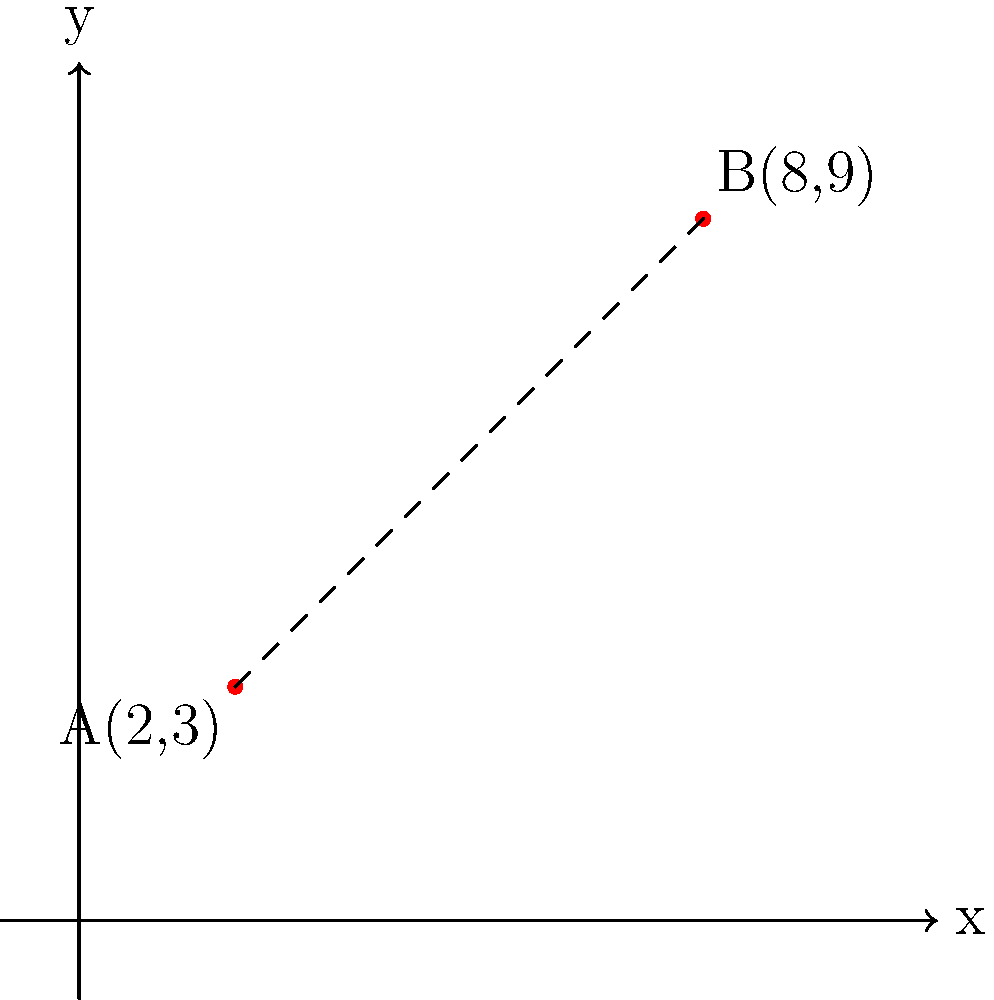In developing a meditation app, you're working on a feature that visualizes sound waves. Two peaks in a particular ambient soundscape are represented as points A(2,3) and B(8,9) on a coordinate system. Calculate the distance between these two sound wave peaks to help determine the spatial effect in the audio mix. To find the distance between two points in a coordinate system, we can use the distance formula, which is derived from the Pythagorean theorem:

$$d = \sqrt{(x_2 - x_1)^2 + (y_2 - y_1)^2}$$

Where $(x_1, y_1)$ are the coordinates of the first point and $(x_2, y_2)$ are the coordinates of the second point.

Let's solve this step by step:

1) Identify the coordinates:
   Point A: $(x_1, y_1) = (2, 3)$
   Point B: $(x_2, y_2) = (8, 9)$

2) Plug these values into the distance formula:
   $$d = \sqrt{(8 - 2)^2 + (9 - 3)^2}$$

3) Simplify inside the parentheses:
   $$d = \sqrt{6^2 + 6^2}$$

4) Calculate the squares:
   $$d = \sqrt{36 + 36}$$

5) Add under the square root:
   $$d = \sqrt{72}$$

6) Simplify the square root:
   $$d = 6\sqrt{2}$$

Therefore, the distance between the two sound wave peaks is $6\sqrt{2}$ units.
Answer: $6\sqrt{2}$ units 